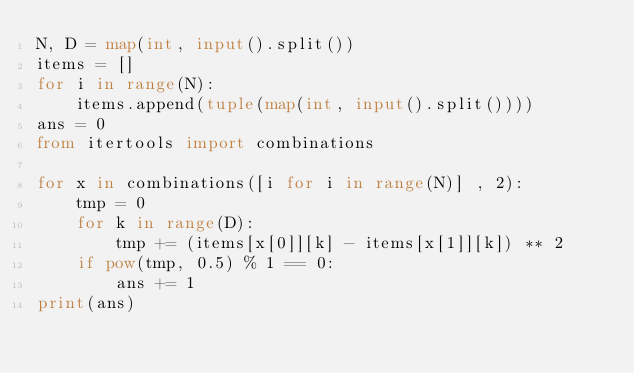<code> <loc_0><loc_0><loc_500><loc_500><_Python_>N, D = map(int, input().split())
items = []
for i in range(N):
    items.append(tuple(map(int, input().split())))
ans = 0
from itertools import combinations

for x in combinations([i for i in range(N)] , 2):
    tmp = 0
    for k in range(D):
        tmp += (items[x[0]][k] - items[x[1]][k]) ** 2
    if pow(tmp, 0.5) % 1 == 0:
        ans += 1
print(ans)
</code> 